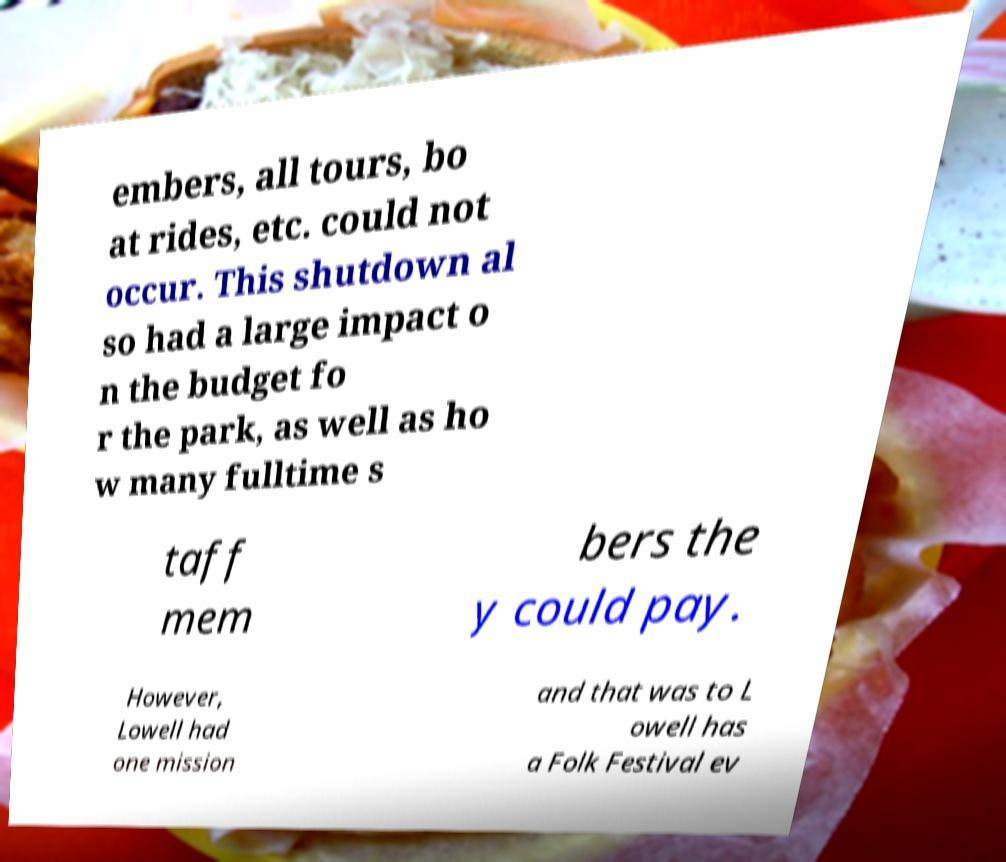Can you read and provide the text displayed in the image?This photo seems to have some interesting text. Can you extract and type it out for me? embers, all tours, bo at rides, etc. could not occur. This shutdown al so had a large impact o n the budget fo r the park, as well as ho w many fulltime s taff mem bers the y could pay. However, Lowell had one mission and that was to L owell has a Folk Festival ev 